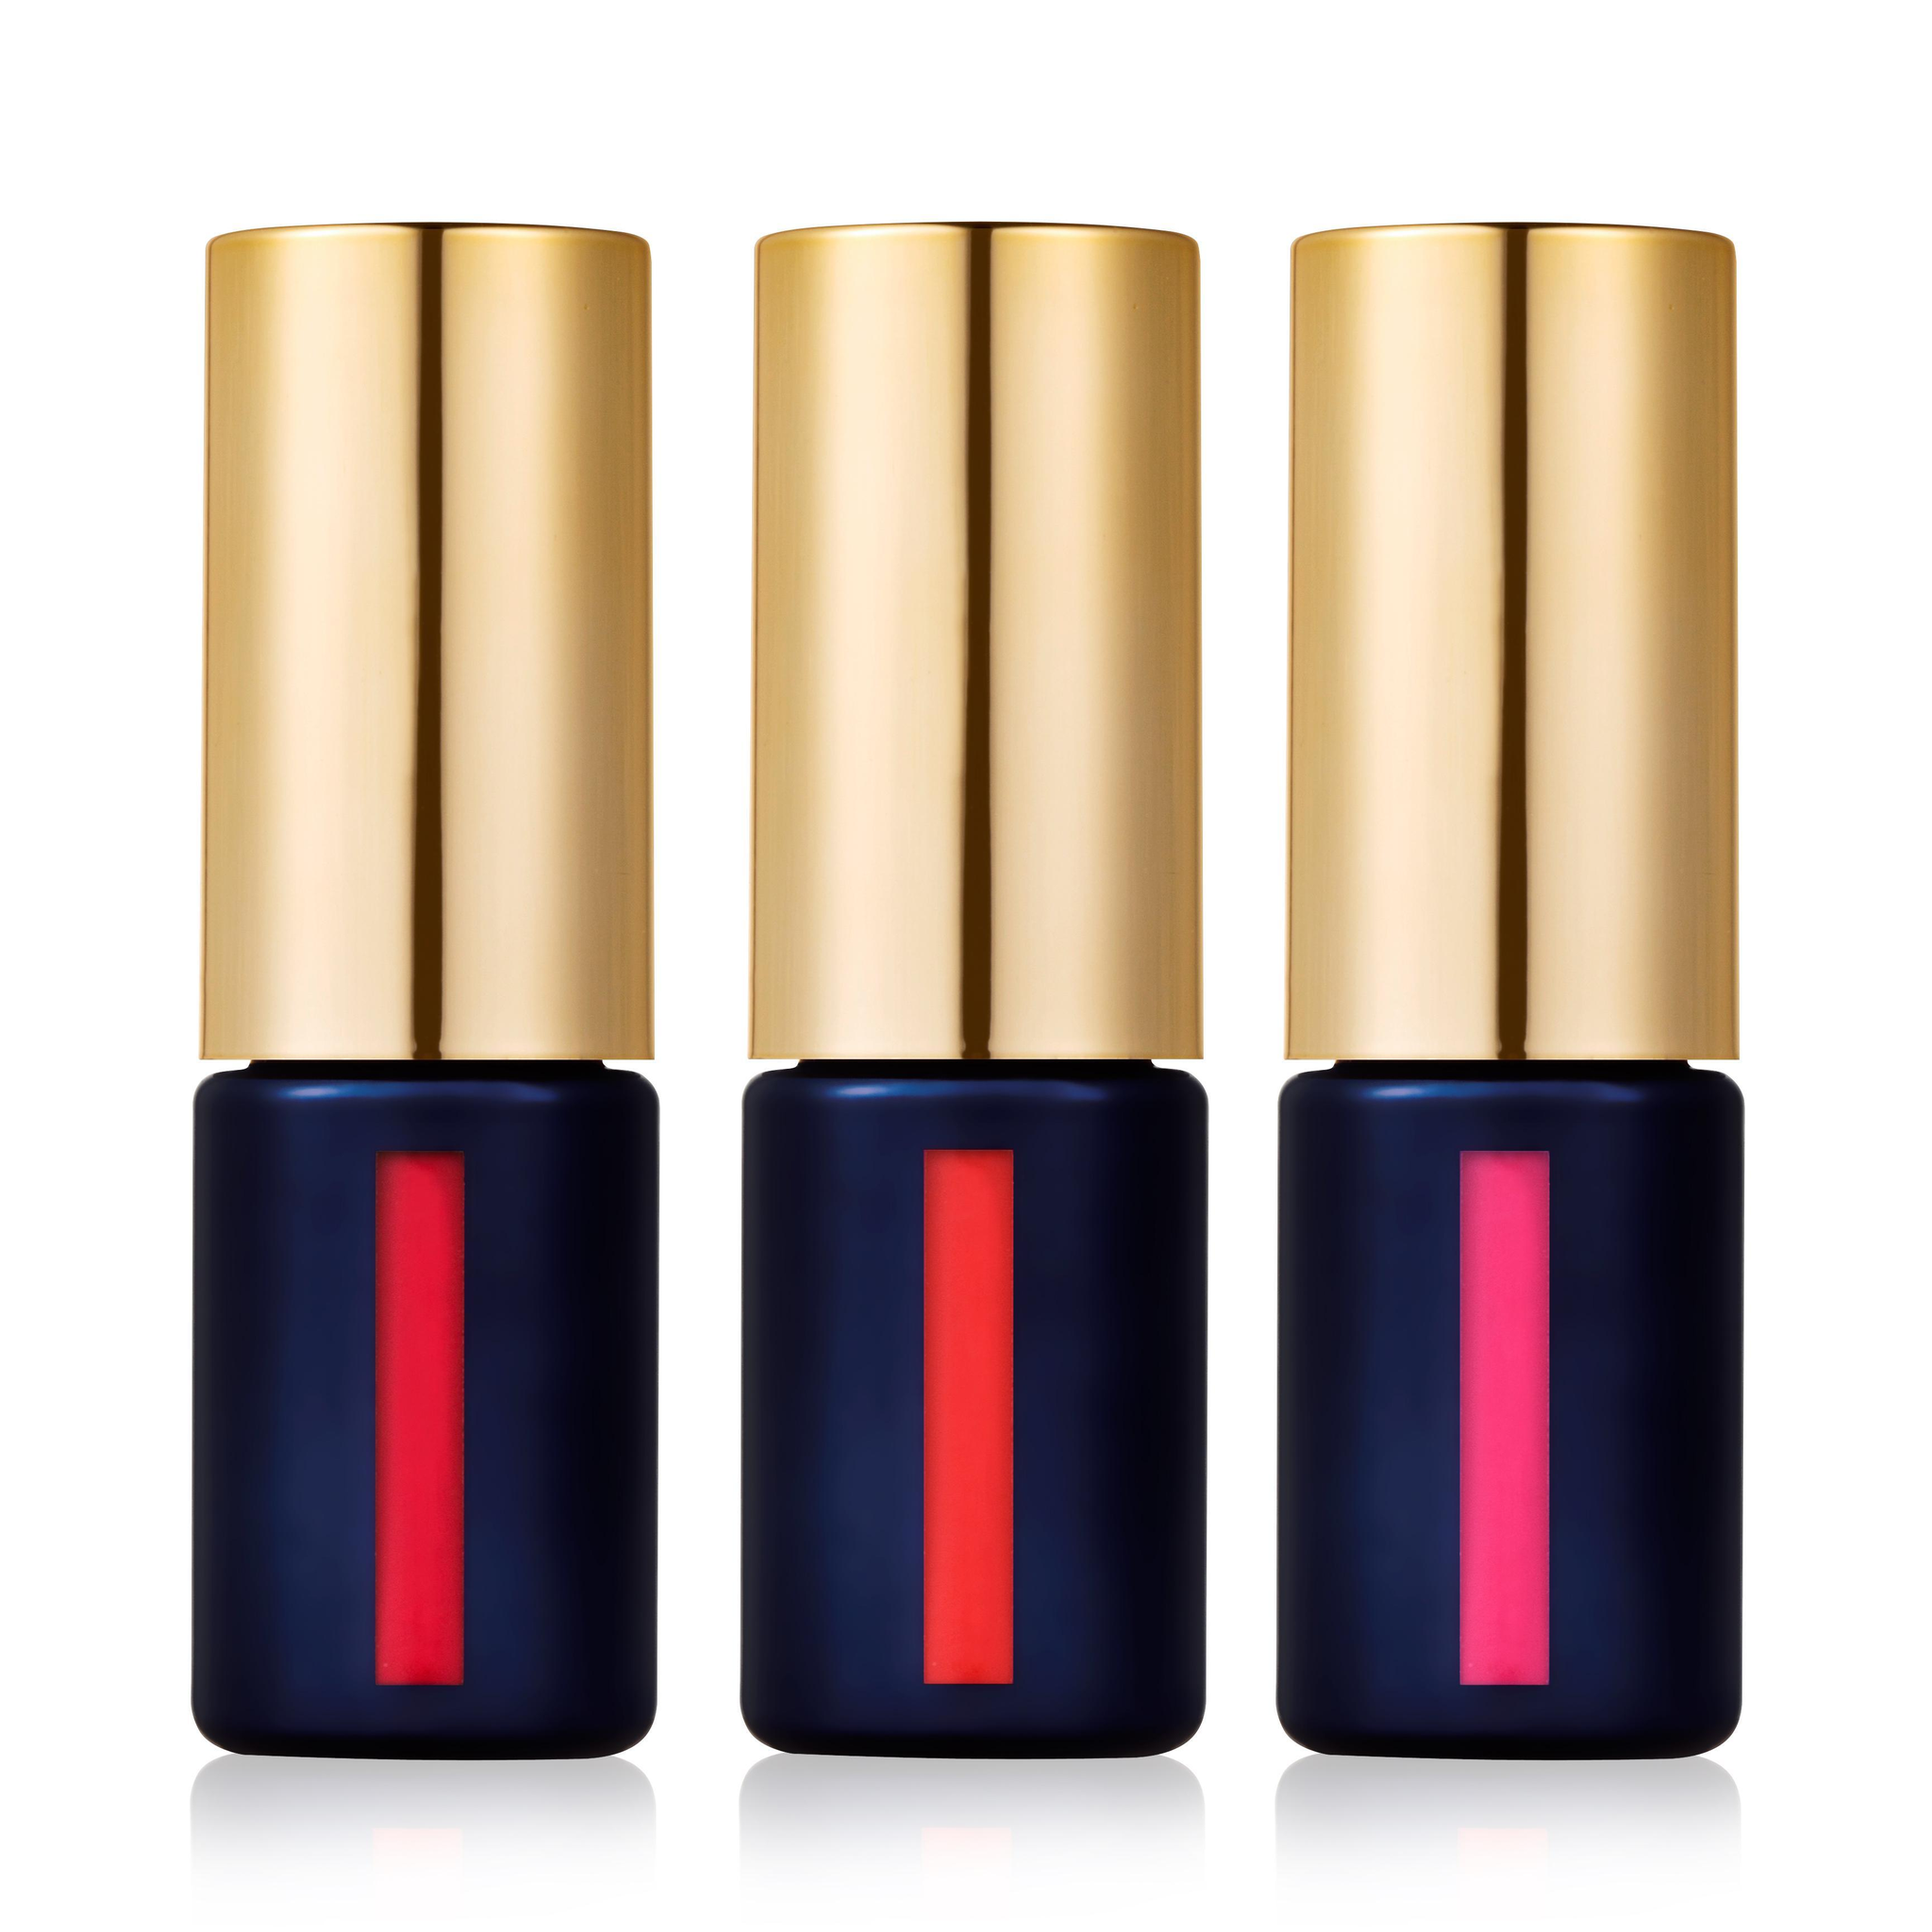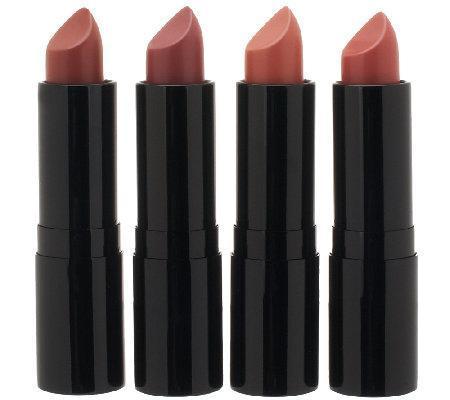The first image is the image on the left, the second image is the image on the right. Assess this claim about the two images: "There are at least six lipsticks in the image on the right.". Correct or not? Answer yes or no. No. 